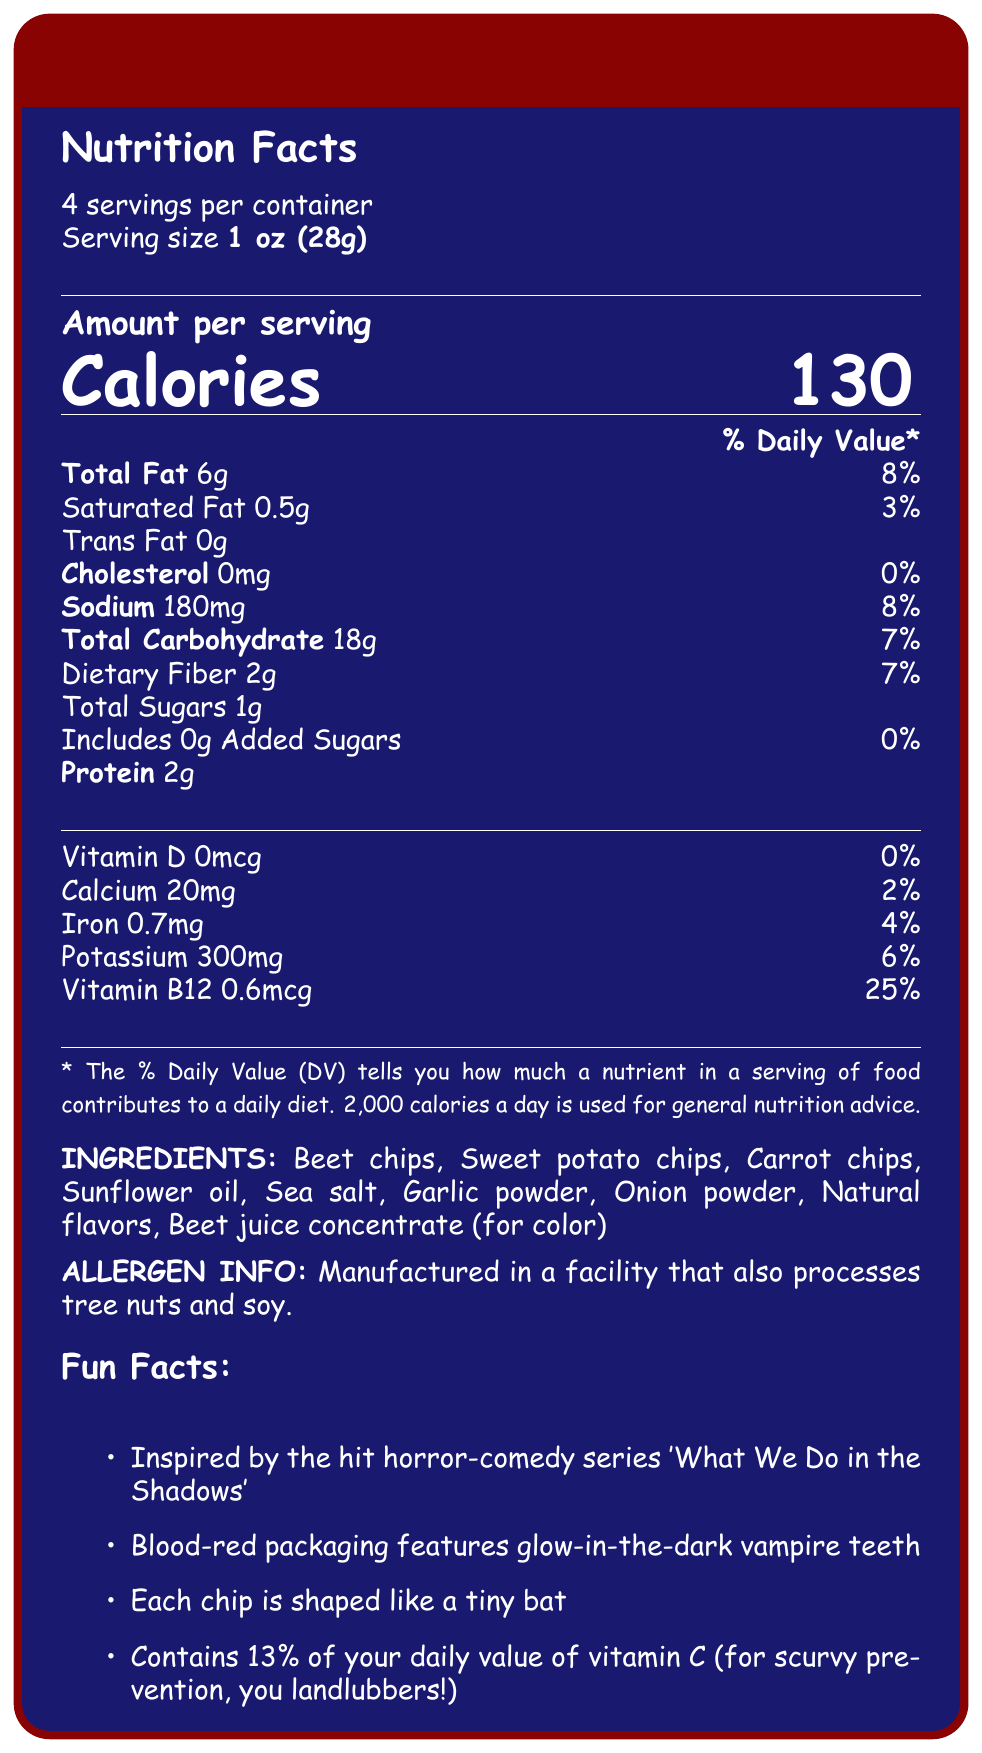what is the serving size of Vampiric Veggie Chips? The serving size is clearly stated under the "Nutrition Facts" section as "1 oz (28g)".
Answer: 1 oz (28g) how many servings are there per container? The document indicates there are "About 4" servings per container.
Answer: About 4 what is the total carbohydrate content per serving? Under the "Nutrition Facts" section, it lists "Total Carbohydrate" as 18g per serving.
Answer: 18g how much potassium is in each serving? The amount of potassium per serving is specified as 300mg under the nutrition breakdown.
Answer: 300mg what are some of the main ingredients in Vampiric Veggie Chips? The ingredients listed in the document include Beet chips, Sweet potato chips, Carrot chips, Sunflower oil, Sea salt, among others.
Answer: Beet chips, Sweet potato chips, Carrot chips, Sunflower oil, Sea salt what percentage of daily value of vitamin B12 does each serving provide? The document states that each serving provides 25% of the daily value for vitamin B12.
Answer: 25% which nutrient has the highest daily value percentage per serving? A. Sodium B. Total Fat C. Vitamin B12 D. Potassium Vitamin B12 has the highest daily value percentage of 25%, higher than any other nutrient listed.
Answer: C. Vitamin B12 what inspired Vampiric Veggie Chips? A. Twilight B. True Blood C. What We Do in the Shadows D. The Walking Dead The "Fun Facts" section mentions that the chips were inspired by the hit horror-comedy series "What We Do in the Shadows".
Answer: C. What We Do in the Shadows do the Vampiric Veggie Chips contain cholesterol? According to the nutrition facts, the document lists "Cholesterol 0mg", indicating there is no cholesterol in the chips.
Answer: No is there any calcium in the Vampiric Veggie Chips? The document notes that each serving contains 20mg of calcium.
Answer: Yes summarize the main idea of the document. The document provides a detailed nutrition breakdown of Vampiric Veggie Chips, along with ingredient and allergen information. It also includes interesting facts and trivia, highlighting the product's horror-comedy theme and creative packaging inspired by "What We Do in the Shadows".
Answer: Vampiric Veggie Chips are a creatively themed snack inspired by the horror-comedy series "What We Do in the Shadows". Each serving provides 130 calories and various nutrients, with unique features like glow-in-the-dark vampire teeth packaging and bat-shaped chips. The document includes nutrition facts, ingredients, allergen information, and some fun trivia about the product's creation and design. how much added sugar is in each serving of the chips? The document lists "Includes 0g Added Sugars", indicating there is no added sugar in each serving.
Answer: 0g where was the packaging design inspiration from? The "trivia" section mentions that Graham Humphreys, known for 'Evil Dead' posters, designed the packaging.
Answer: Graham Humphreys how much iron does each serving contain? The document specifies that each serving contains 0.7mg of iron.
Answer: 0.7mg what is the exact amount of dietary fiber per serving? According to the nutrition facts, each serving contains 2g of dietary fiber.
Answer: 2g which vitamin content is not available in the Vampiric Veggie Chips? The document indicates "Vitamin D 0mcg", meaning there is no Vitamin D in the chips.
Answer: Vitamin D which limited edition flavor was ad-libbed as a slogan by Matt Berry? The document does mention ad-libbing the product’s slogan by Matt Berry, but it does not connect this specifically to any limited edition flavor like 'Werewolf Wasabi' or 'Ghostly Garlic'.
Answer: Not enough information 